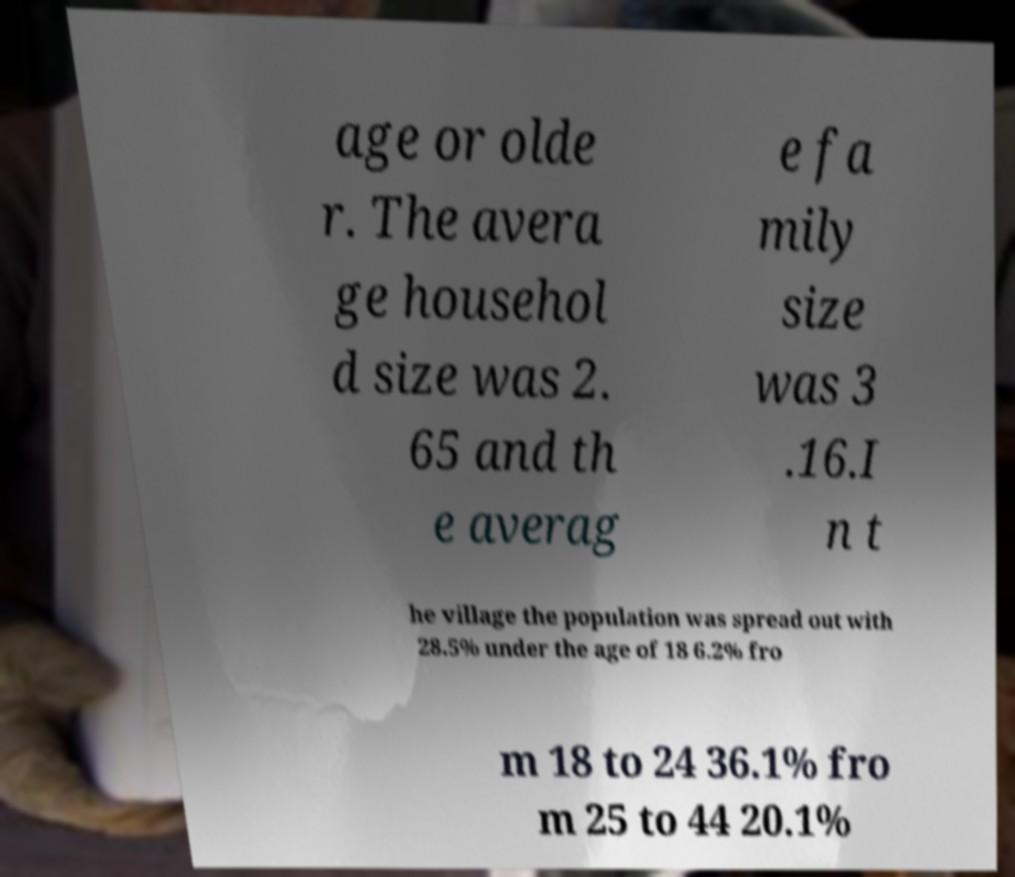For documentation purposes, I need the text within this image transcribed. Could you provide that? age or olde r. The avera ge househol d size was 2. 65 and th e averag e fa mily size was 3 .16.I n t he village the population was spread out with 28.5% under the age of 18 6.2% fro m 18 to 24 36.1% fro m 25 to 44 20.1% 